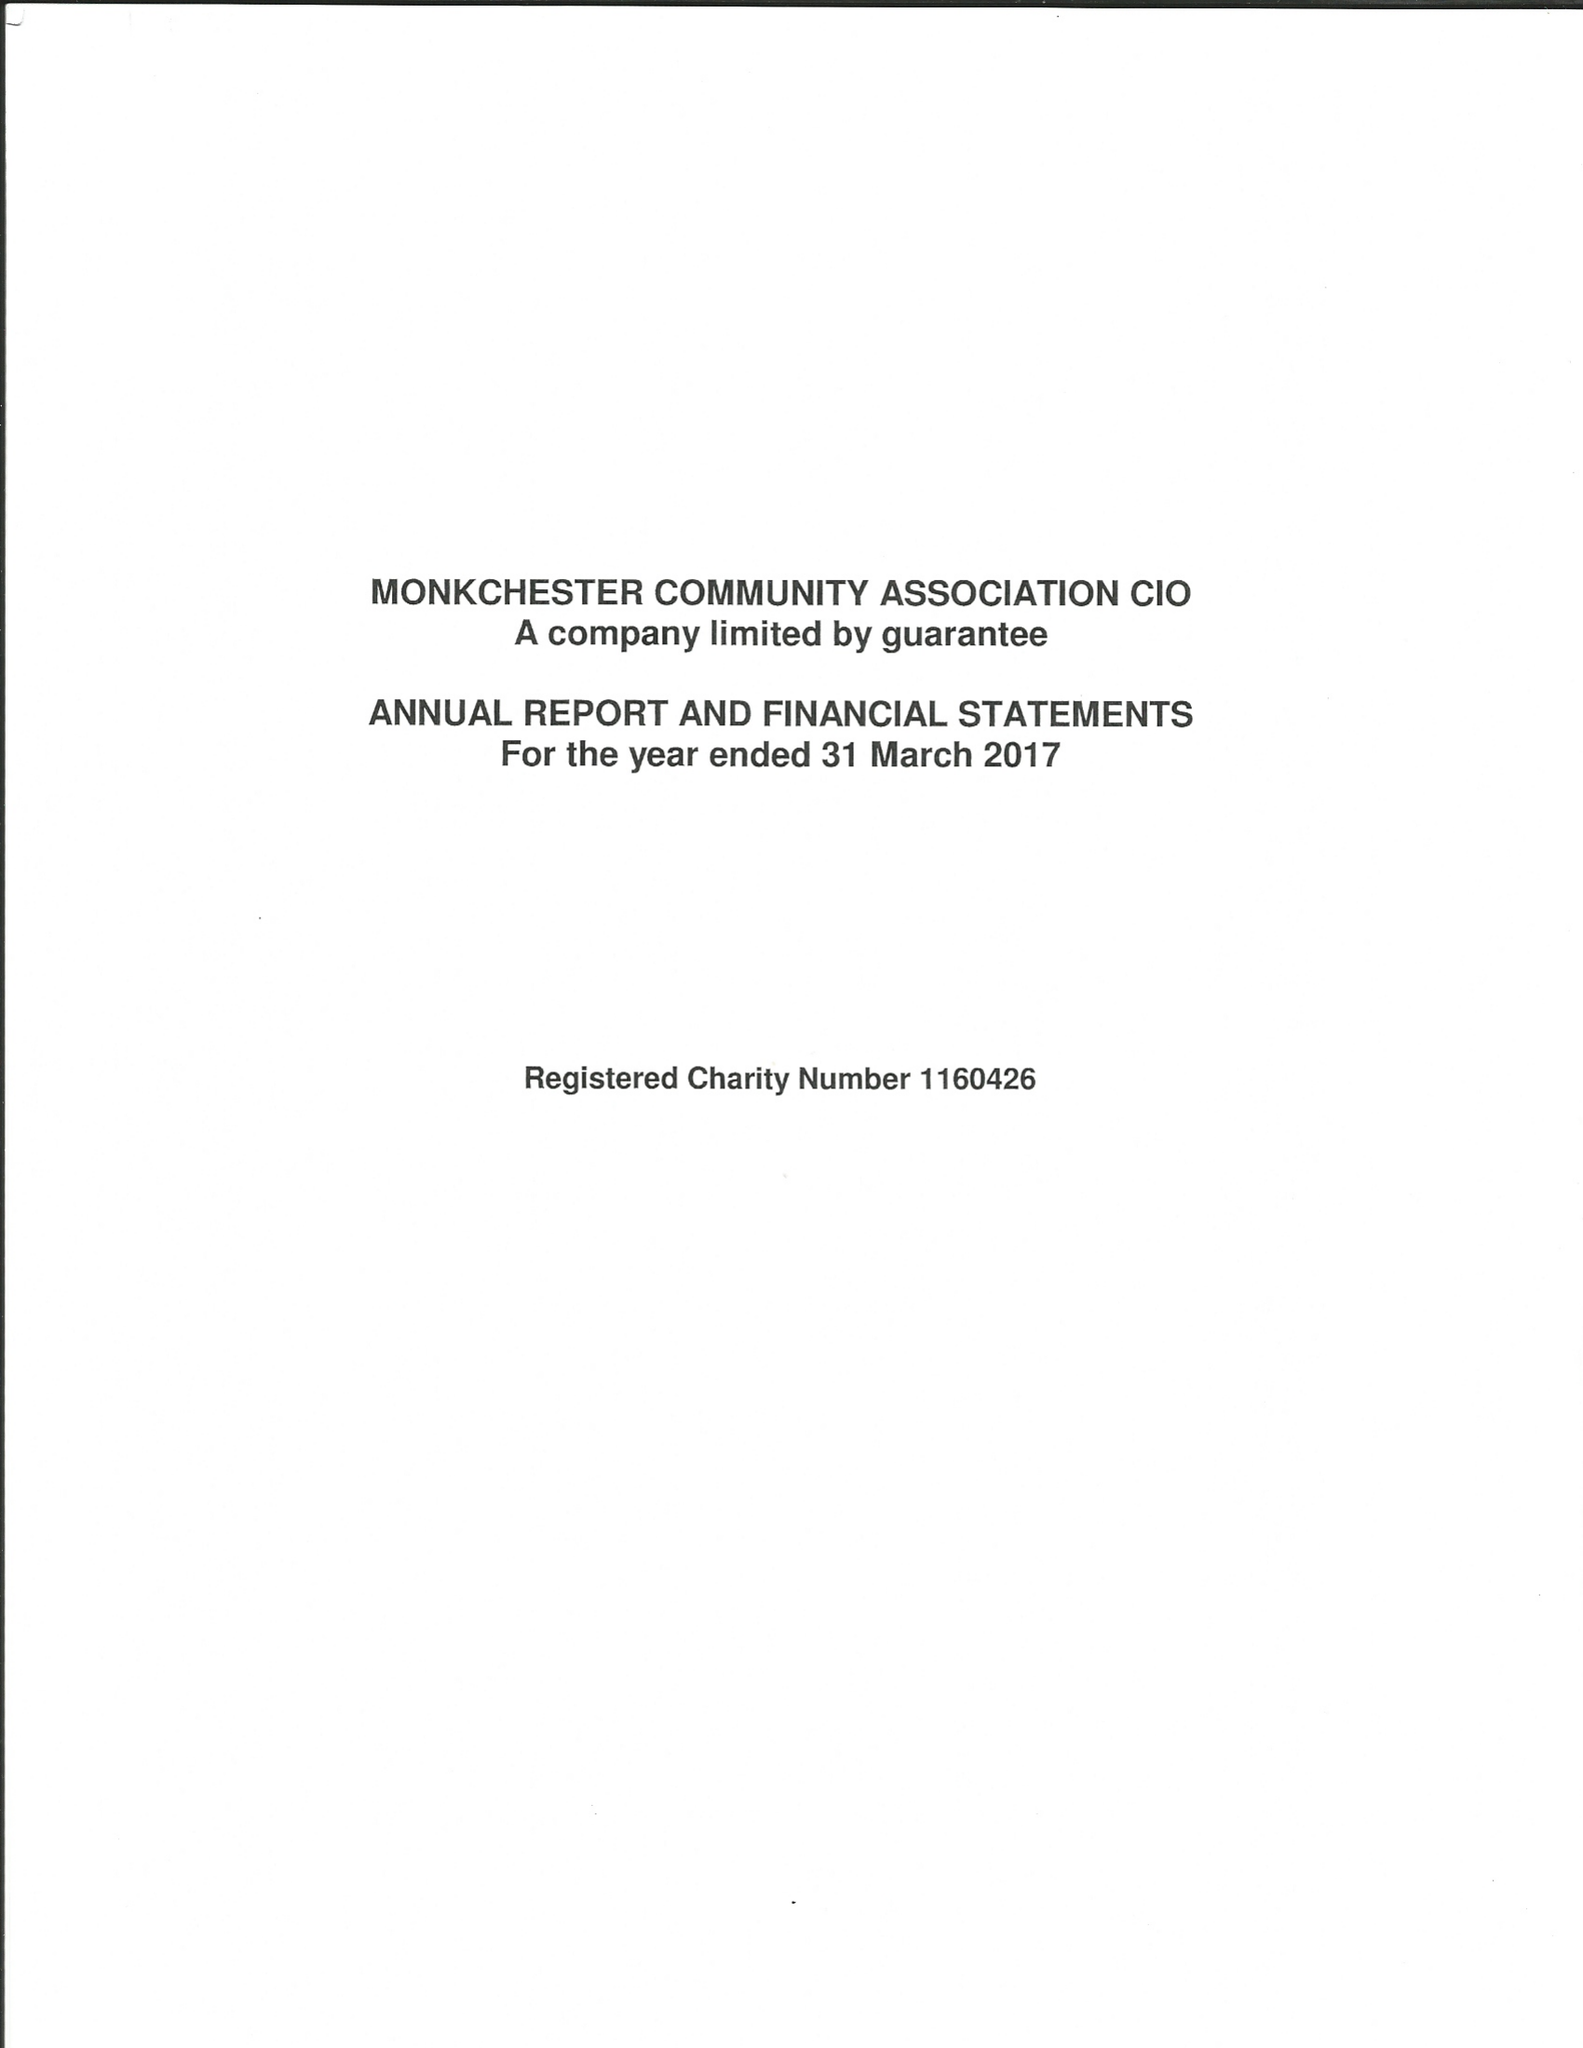What is the value for the address__post_town?
Answer the question using a single word or phrase. NEWCASTLE UPON TYNE 